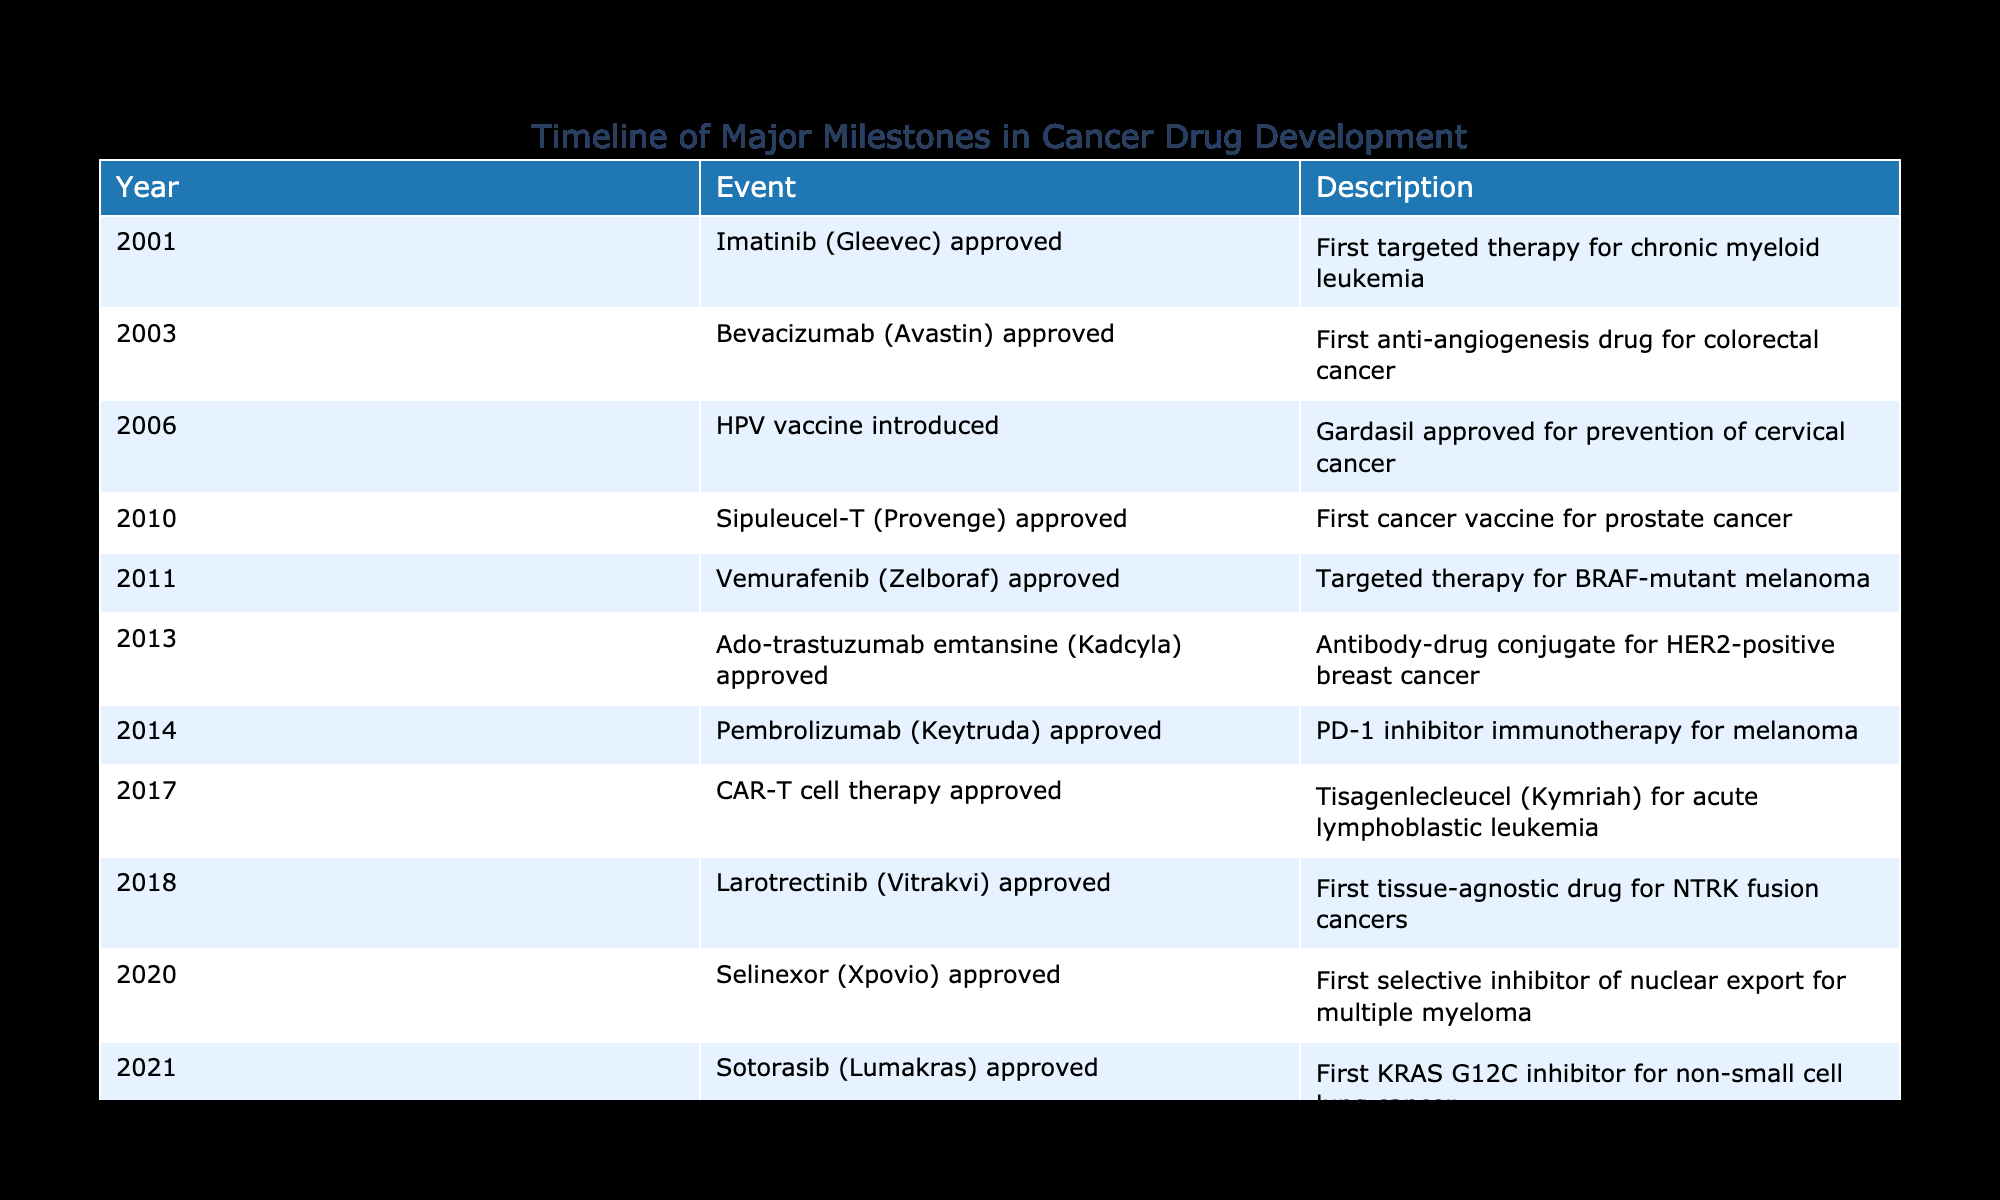What year was Imatinib (Gleevec) approved? According to the table, Imatinib (Gleevec) was approved in the year 2001.
Answer: 2001 Which drug was the first anti-angiogenesis drug for colorectal cancer? The table specifies that Bevacizumab (Avastin) was the first anti-angiogenesis drug for colorectal cancer, and it was approved in 2003.
Answer: Bevacizumab (Avastin) What is the total number of drugs approved between 2010 and 2015? According to the table, the drugs approved between 2010 and 2015 are: Sipuleucel-T (2010), Vemurafenib (2011), Ado-trastuzumab emtansine (2013), and Pembrolizumab (2014). This totals to 4 drugs.
Answer: 4 Was there a cancer vaccine approved before 2015? The table indicates that Sipuleucel-T, the first cancer vaccine for prostate cancer, was approved in 2010, which is before 2015.
Answer: Yes What are the two latest drug approvals listed in the table, and in what year were they approved? The two latest drug approvals in the table are Sotorasib (Lumakras) and Selinexor (Xpovio), which were approved in 2021 and 2020 respectively.
Answer: Sotorasib (Lumakras) in 2021, Selinexor (Xpovio) in 2020 